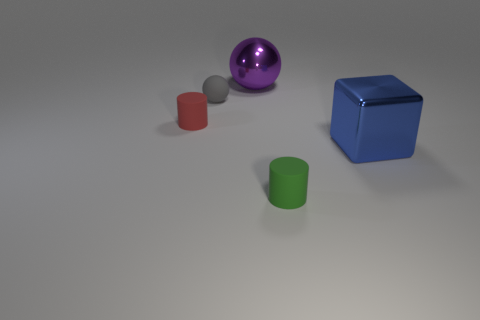There is a shiny ball; is it the same color as the shiny thing that is in front of the red cylinder? no 